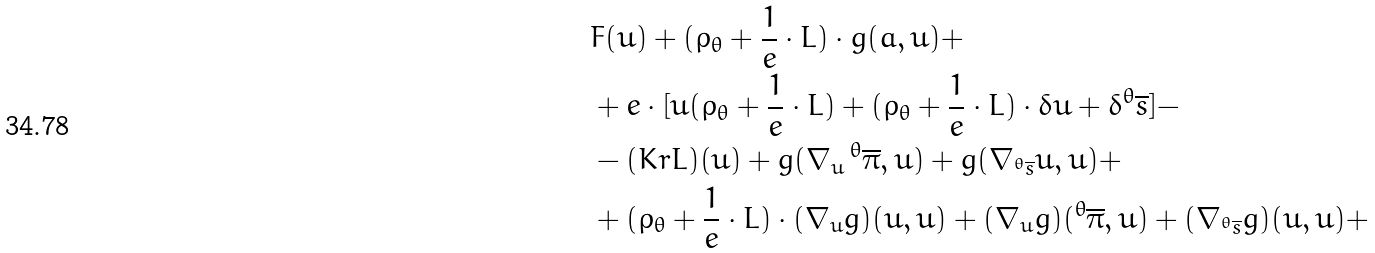Convert formula to latex. <formula><loc_0><loc_0><loc_500><loc_500>& F ( u ) + ( \rho _ { \theta } + \frac { 1 } { e } \cdot L ) \cdot g ( a , u ) + \\ & + e \cdot [ u ( \rho _ { \theta } + \frac { 1 } { e } \cdot L ) + ( \rho _ { \theta } + \frac { 1 } { e } \cdot L ) \cdot \delta u + \delta ^ { \theta } \overline { s } ] - \\ & - ( K r L ) ( u ) + g ( \nabla _ { u } \, ^ { \theta } \overline { \pi } , u ) + g ( \nabla _ { ^ { \theta } \overline { s } } u , u ) + \\ & + ( \rho _ { \theta } + \frac { 1 } { e } \cdot L ) \cdot ( \nabla _ { u } g ) ( u , u ) + ( \nabla _ { u } g ) ( ^ { \theta } \overline { \pi } , u ) + ( \nabla _ { ^ { \theta } \overline { s } } g ) ( u , u ) +</formula> 